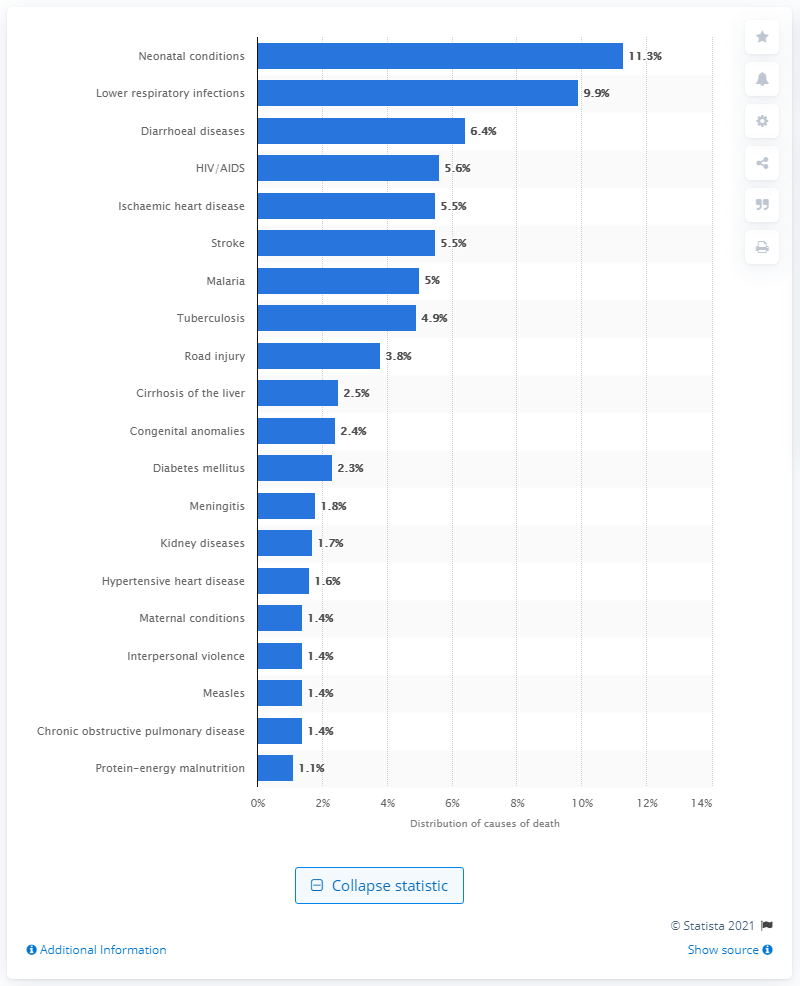Outline some significant characteristics in this image. According to the data, lower respiratory infections accounted for 9.9% of all deaths. In 2019, neonatal conditions were responsible for 11.3% of all deaths in Africa. 